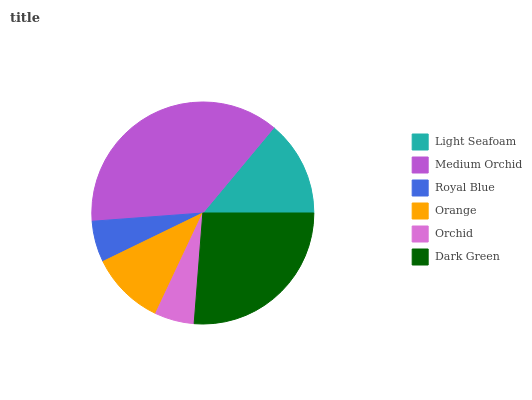Is Orchid the minimum?
Answer yes or no. Yes. Is Medium Orchid the maximum?
Answer yes or no. Yes. Is Royal Blue the minimum?
Answer yes or no. No. Is Royal Blue the maximum?
Answer yes or no. No. Is Medium Orchid greater than Royal Blue?
Answer yes or no. Yes. Is Royal Blue less than Medium Orchid?
Answer yes or no. Yes. Is Royal Blue greater than Medium Orchid?
Answer yes or no. No. Is Medium Orchid less than Royal Blue?
Answer yes or no. No. Is Light Seafoam the high median?
Answer yes or no. Yes. Is Orange the low median?
Answer yes or no. Yes. Is Orchid the high median?
Answer yes or no. No. Is Medium Orchid the low median?
Answer yes or no. No. 